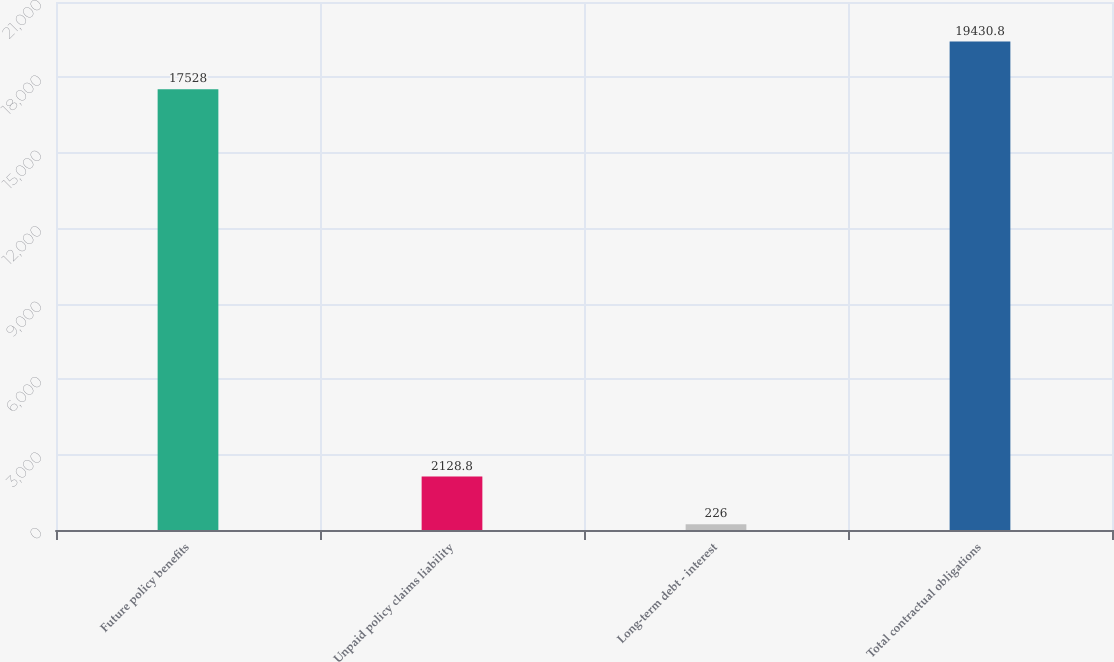Convert chart. <chart><loc_0><loc_0><loc_500><loc_500><bar_chart><fcel>Future policy benefits<fcel>Unpaid policy claims liability<fcel>Long-term debt - interest<fcel>Total contractual obligations<nl><fcel>17528<fcel>2128.8<fcel>226<fcel>19430.8<nl></chart> 